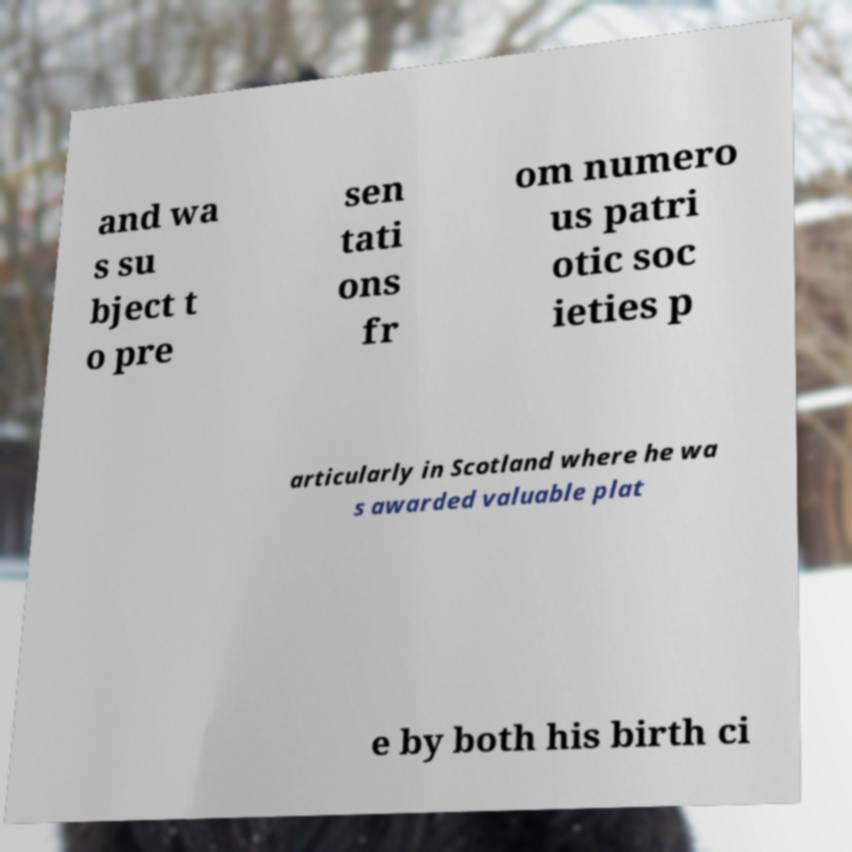Can you read and provide the text displayed in the image?This photo seems to have some interesting text. Can you extract and type it out for me? and wa s su bject t o pre sen tati ons fr om numero us patri otic soc ieties p articularly in Scotland where he wa s awarded valuable plat e by both his birth ci 